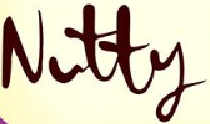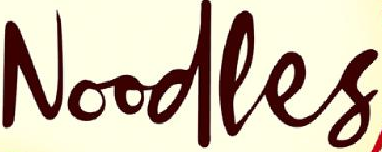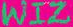Read the text from these images in sequence, separated by a semicolon. Nutty; Noodles; WIZ 